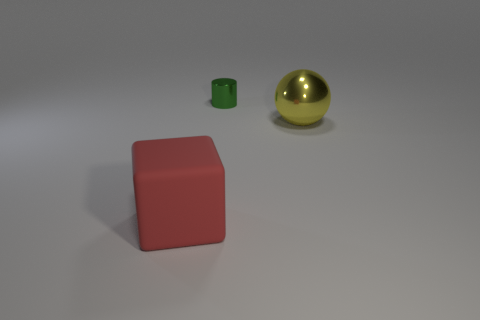Add 1 small red metallic spheres. How many objects exist? 4 Subtract all blocks. How many objects are left? 2 Add 3 big red things. How many big red things exist? 4 Subtract 0 cyan cylinders. How many objects are left? 3 Subtract all yellow cylinders. Subtract all metallic balls. How many objects are left? 2 Add 3 large red rubber blocks. How many large red rubber blocks are left? 4 